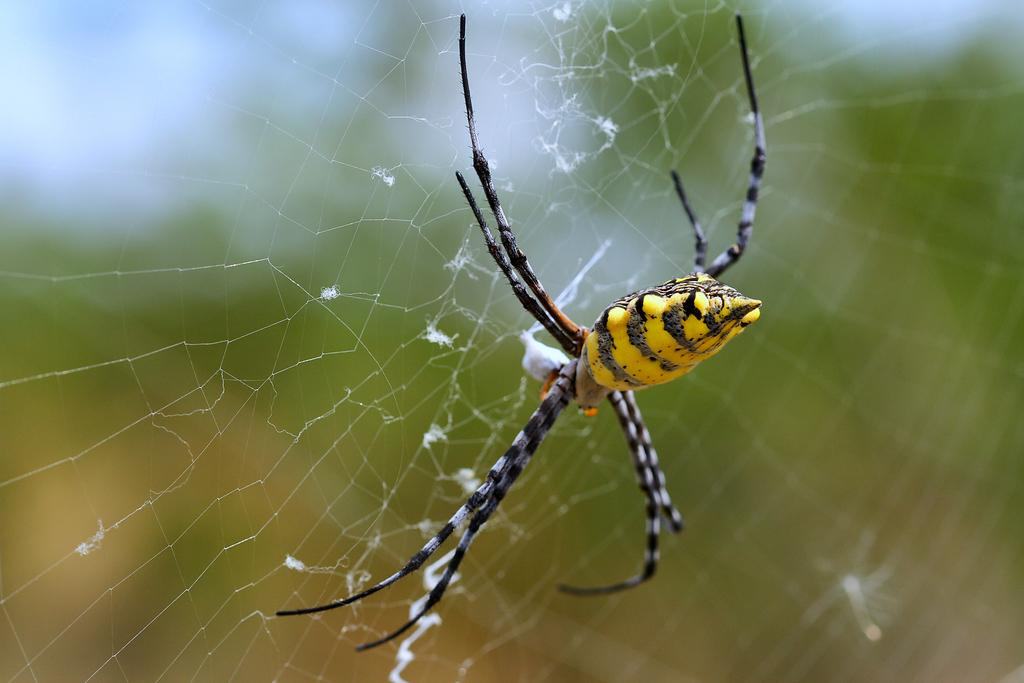What is the main subject of the image? There is a spider in the image. Where is the spider located? The spider is on a web. How is the image composed in terms of focus? The foreground area of the image is in focus, while the background is blurry. How many knots are tied in the spider's web in the image? There is no mention of knots in the spider's web in the image, so we cannot determine the number of knots. What time is displayed on the clocks in the image? There are no clocks present in the image. 